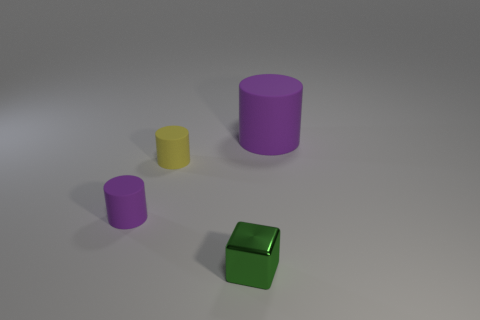What color is the other matte object that is the same size as the yellow matte thing?
Give a very brief answer. Purple. Is the size of the yellow matte cylinder the same as the green object?
Your response must be concise. Yes. What number of tiny green metallic blocks are to the left of the tiny purple cylinder?
Give a very brief answer. 0. How many objects are either purple rubber cylinders that are left of the small yellow matte object or large purple rubber cylinders?
Offer a terse response. 2. Is the number of cylinders left of the small shiny cube greater than the number of purple rubber cylinders on the right side of the big purple rubber cylinder?
Make the answer very short. Yes. The other matte cylinder that is the same color as the big cylinder is what size?
Provide a short and direct response. Small. Is the size of the shiny block the same as the purple matte object right of the green metallic cube?
Offer a very short reply. No. What number of spheres are either large matte things or small shiny things?
Your response must be concise. 0. What is the size of the yellow object that is made of the same material as the big cylinder?
Keep it short and to the point. Small. Do the cylinder on the right side of the green object and the thing in front of the small purple thing have the same size?
Your answer should be compact. No. 